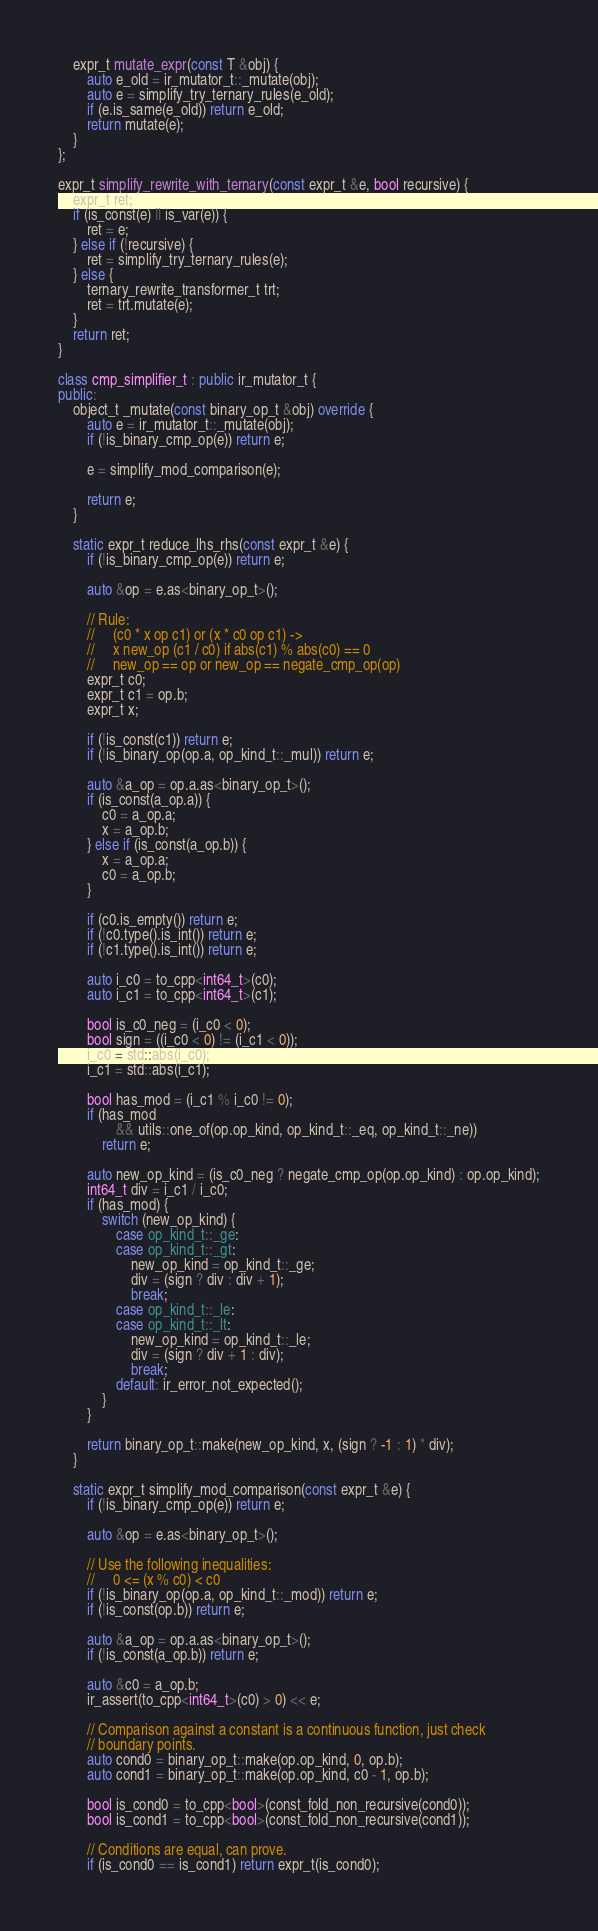<code> <loc_0><loc_0><loc_500><loc_500><_C++_>    expr_t mutate_expr(const T &obj) {
        auto e_old = ir_mutator_t::_mutate(obj);
        auto e = simplify_try_ternary_rules(e_old);
        if (e.is_same(e_old)) return e_old;
        return mutate(e);
    }
};

expr_t simplify_rewrite_with_ternary(const expr_t &e, bool recursive) {
    expr_t ret;
    if (is_const(e) || is_var(e)) {
        ret = e;
    } else if (!recursive) {
        ret = simplify_try_ternary_rules(e);
    } else {
        ternary_rewrite_transformer_t trt;
        ret = trt.mutate(e);
    }
    return ret;
}

class cmp_simplifier_t : public ir_mutator_t {
public:
    object_t _mutate(const binary_op_t &obj) override {
        auto e = ir_mutator_t::_mutate(obj);
        if (!is_binary_cmp_op(e)) return e;

        e = simplify_mod_comparison(e);

        return e;
    }

    static expr_t reduce_lhs_rhs(const expr_t &e) {
        if (!is_binary_cmp_op(e)) return e;

        auto &op = e.as<binary_op_t>();

        // Rule:
        //     (c0 * x op c1) or (x * c0 op c1) ->
        //     x new_op (c1 / c0) if abs(c1) % abs(c0) == 0
        //     new_op == op or new_op == negate_cmp_op(op)
        expr_t c0;
        expr_t c1 = op.b;
        expr_t x;

        if (!is_const(c1)) return e;
        if (!is_binary_op(op.a, op_kind_t::_mul)) return e;

        auto &a_op = op.a.as<binary_op_t>();
        if (is_const(a_op.a)) {
            c0 = a_op.a;
            x = a_op.b;
        } else if (is_const(a_op.b)) {
            x = a_op.a;
            c0 = a_op.b;
        }

        if (c0.is_empty()) return e;
        if (!c0.type().is_int()) return e;
        if (!c1.type().is_int()) return e;

        auto i_c0 = to_cpp<int64_t>(c0);
        auto i_c1 = to_cpp<int64_t>(c1);

        bool is_c0_neg = (i_c0 < 0);
        bool sign = ((i_c0 < 0) != (i_c1 < 0));
        i_c0 = std::abs(i_c0);
        i_c1 = std::abs(i_c1);

        bool has_mod = (i_c1 % i_c0 != 0);
        if (has_mod
                && utils::one_of(op.op_kind, op_kind_t::_eq, op_kind_t::_ne))
            return e;

        auto new_op_kind = (is_c0_neg ? negate_cmp_op(op.op_kind) : op.op_kind);
        int64_t div = i_c1 / i_c0;
        if (has_mod) {
            switch (new_op_kind) {
                case op_kind_t::_ge:
                case op_kind_t::_gt:
                    new_op_kind = op_kind_t::_ge;
                    div = (sign ? div : div + 1);
                    break;
                case op_kind_t::_le:
                case op_kind_t::_lt:
                    new_op_kind = op_kind_t::_le;
                    div = (sign ? div + 1 : div);
                    break;
                default: ir_error_not_expected();
            }
        }

        return binary_op_t::make(new_op_kind, x, (sign ? -1 : 1) * div);
    }

    static expr_t simplify_mod_comparison(const expr_t &e) {
        if (!is_binary_cmp_op(e)) return e;

        auto &op = e.as<binary_op_t>();

        // Use the following inequalities:
        //     0 <= (x % c0) < c0
        if (!is_binary_op(op.a, op_kind_t::_mod)) return e;
        if (!is_const(op.b)) return e;

        auto &a_op = op.a.as<binary_op_t>();
        if (!is_const(a_op.b)) return e;

        auto &c0 = a_op.b;
        ir_assert(to_cpp<int64_t>(c0) > 0) << e;

        // Comparison against a constant is a continuous function, just check
        // boundary points.
        auto cond0 = binary_op_t::make(op.op_kind, 0, op.b);
        auto cond1 = binary_op_t::make(op.op_kind, c0 - 1, op.b);

        bool is_cond0 = to_cpp<bool>(const_fold_non_recursive(cond0));
        bool is_cond1 = to_cpp<bool>(const_fold_non_recursive(cond1));

        // Conditions are equal, can prove.
        if (is_cond0 == is_cond1) return expr_t(is_cond0);
</code> 